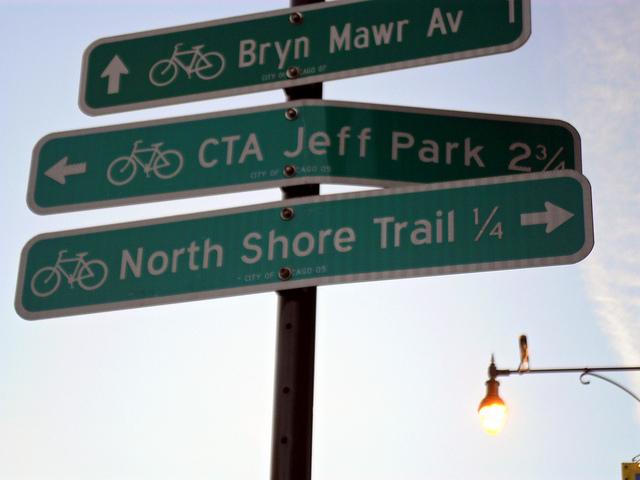What trail is to the right?
Answer briefly. North shore. Are the street signs solid?
Write a very short answer. Yes. How far away is North Shore Trail?
Answer briefly. 1/4 mile. How many signs are shown?
Give a very brief answer. 3. 